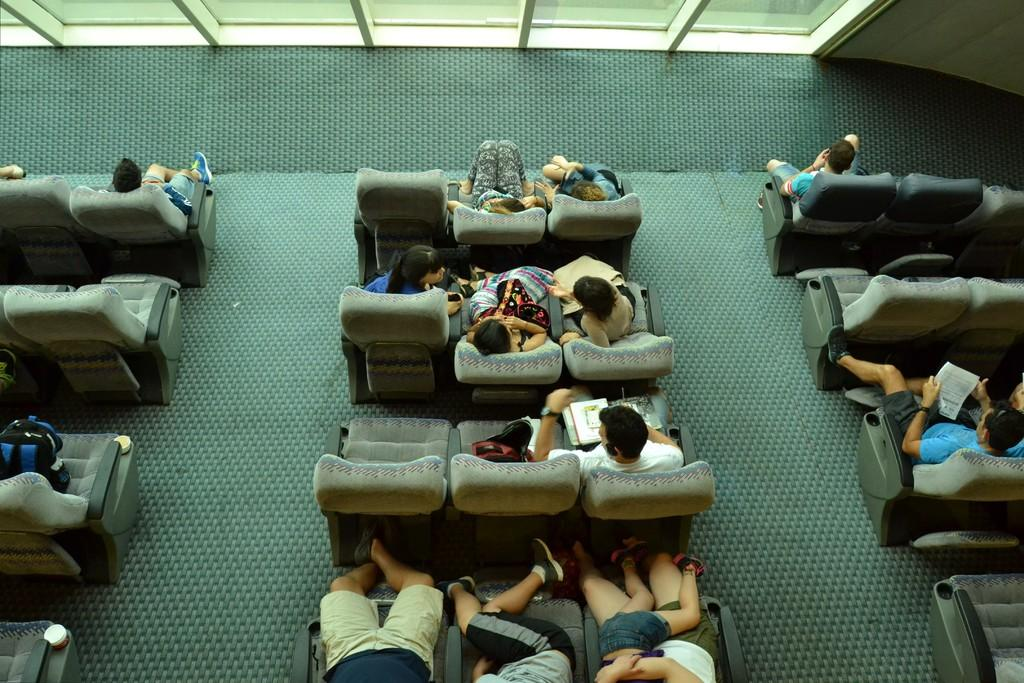What are the people in the image doing? The people in the image are sitting on chairs. What are some of the people holding in the image? Some people are holding a book in the image. What is the background of the image like? There is a wall and a window beside the wall in the image. What type of letter can be seen in the image? There is no letter present in the image. 